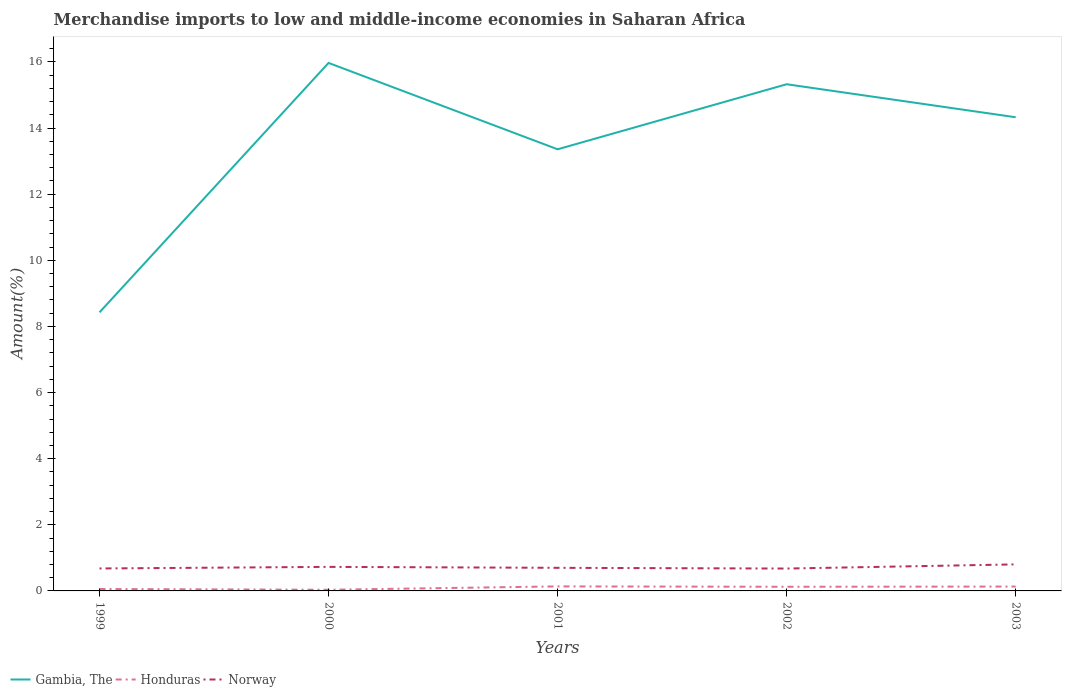How many different coloured lines are there?
Make the answer very short. 3. Does the line corresponding to Gambia, The intersect with the line corresponding to Honduras?
Your answer should be compact. No. Is the number of lines equal to the number of legend labels?
Provide a succinct answer. Yes. Across all years, what is the maximum percentage of amount earned from merchandise imports in Norway?
Your answer should be compact. 0.68. In which year was the percentage of amount earned from merchandise imports in Honduras maximum?
Your answer should be very brief. 2000. What is the total percentage of amount earned from merchandise imports in Norway in the graph?
Provide a short and direct response. 0.05. What is the difference between the highest and the second highest percentage of amount earned from merchandise imports in Honduras?
Your answer should be very brief. 0.1. Is the percentage of amount earned from merchandise imports in Honduras strictly greater than the percentage of amount earned from merchandise imports in Norway over the years?
Keep it short and to the point. Yes. Are the values on the major ticks of Y-axis written in scientific E-notation?
Give a very brief answer. No. Does the graph contain any zero values?
Offer a very short reply. No. Does the graph contain grids?
Make the answer very short. No. Where does the legend appear in the graph?
Your response must be concise. Bottom left. How many legend labels are there?
Offer a terse response. 3. How are the legend labels stacked?
Provide a short and direct response. Horizontal. What is the title of the graph?
Your response must be concise. Merchandise imports to low and middle-income economies in Saharan Africa. Does "Micronesia" appear as one of the legend labels in the graph?
Provide a short and direct response. No. What is the label or title of the X-axis?
Keep it short and to the point. Years. What is the label or title of the Y-axis?
Provide a short and direct response. Amount(%). What is the Amount(%) in Gambia, The in 1999?
Your response must be concise. 8.43. What is the Amount(%) of Honduras in 1999?
Provide a succinct answer. 0.06. What is the Amount(%) of Norway in 1999?
Provide a succinct answer. 0.68. What is the Amount(%) in Gambia, The in 2000?
Offer a very short reply. 15.97. What is the Amount(%) of Honduras in 2000?
Your response must be concise. 0.04. What is the Amount(%) of Norway in 2000?
Give a very brief answer. 0.73. What is the Amount(%) in Gambia, The in 2001?
Offer a terse response. 13.36. What is the Amount(%) in Honduras in 2001?
Offer a terse response. 0.14. What is the Amount(%) in Norway in 2001?
Provide a short and direct response. 0.7. What is the Amount(%) of Gambia, The in 2002?
Offer a very short reply. 15.33. What is the Amount(%) of Honduras in 2002?
Your answer should be compact. 0.13. What is the Amount(%) in Norway in 2002?
Offer a very short reply. 0.68. What is the Amount(%) in Gambia, The in 2003?
Your answer should be very brief. 14.33. What is the Amount(%) in Honduras in 2003?
Provide a short and direct response. 0.13. What is the Amount(%) of Norway in 2003?
Give a very brief answer. 0.8. Across all years, what is the maximum Amount(%) of Gambia, The?
Your answer should be compact. 15.97. Across all years, what is the maximum Amount(%) in Honduras?
Make the answer very short. 0.14. Across all years, what is the maximum Amount(%) in Norway?
Keep it short and to the point. 0.8. Across all years, what is the minimum Amount(%) in Gambia, The?
Your answer should be compact. 8.43. Across all years, what is the minimum Amount(%) in Honduras?
Give a very brief answer. 0.04. Across all years, what is the minimum Amount(%) in Norway?
Offer a terse response. 0.68. What is the total Amount(%) in Gambia, The in the graph?
Your answer should be compact. 67.41. What is the total Amount(%) in Honduras in the graph?
Offer a very short reply. 0.49. What is the total Amount(%) of Norway in the graph?
Give a very brief answer. 3.58. What is the difference between the Amount(%) in Gambia, The in 1999 and that in 2000?
Keep it short and to the point. -7.54. What is the difference between the Amount(%) in Honduras in 1999 and that in 2000?
Your answer should be compact. 0.02. What is the difference between the Amount(%) of Norway in 1999 and that in 2000?
Offer a very short reply. -0.05. What is the difference between the Amount(%) of Gambia, The in 1999 and that in 2001?
Offer a terse response. -4.93. What is the difference between the Amount(%) of Honduras in 1999 and that in 2001?
Provide a succinct answer. -0.08. What is the difference between the Amount(%) of Norway in 1999 and that in 2001?
Your answer should be compact. -0.02. What is the difference between the Amount(%) of Gambia, The in 1999 and that in 2002?
Keep it short and to the point. -6.9. What is the difference between the Amount(%) of Honduras in 1999 and that in 2002?
Provide a succinct answer. -0.07. What is the difference between the Amount(%) in Norway in 1999 and that in 2002?
Provide a succinct answer. 0. What is the difference between the Amount(%) in Gambia, The in 1999 and that in 2003?
Your response must be concise. -5.9. What is the difference between the Amount(%) in Honduras in 1999 and that in 2003?
Offer a very short reply. -0.07. What is the difference between the Amount(%) of Norway in 1999 and that in 2003?
Your answer should be very brief. -0.12. What is the difference between the Amount(%) in Gambia, The in 2000 and that in 2001?
Provide a succinct answer. 2.61. What is the difference between the Amount(%) of Honduras in 2000 and that in 2001?
Your answer should be very brief. -0.1. What is the difference between the Amount(%) of Norway in 2000 and that in 2001?
Provide a succinct answer. 0.03. What is the difference between the Amount(%) in Gambia, The in 2000 and that in 2002?
Offer a very short reply. 0.65. What is the difference between the Amount(%) of Honduras in 2000 and that in 2002?
Offer a very short reply. -0.09. What is the difference between the Amount(%) of Norway in 2000 and that in 2002?
Ensure brevity in your answer.  0.05. What is the difference between the Amount(%) of Gambia, The in 2000 and that in 2003?
Your answer should be very brief. 1.64. What is the difference between the Amount(%) of Honduras in 2000 and that in 2003?
Your answer should be compact. -0.1. What is the difference between the Amount(%) of Norway in 2000 and that in 2003?
Give a very brief answer. -0.08. What is the difference between the Amount(%) of Gambia, The in 2001 and that in 2002?
Provide a short and direct response. -1.97. What is the difference between the Amount(%) of Honduras in 2001 and that in 2002?
Offer a very short reply. 0.01. What is the difference between the Amount(%) in Norway in 2001 and that in 2002?
Give a very brief answer. 0.02. What is the difference between the Amount(%) of Gambia, The in 2001 and that in 2003?
Your response must be concise. -0.97. What is the difference between the Amount(%) in Honduras in 2001 and that in 2003?
Make the answer very short. 0. What is the difference between the Amount(%) of Norway in 2001 and that in 2003?
Offer a terse response. -0.1. What is the difference between the Amount(%) of Honduras in 2002 and that in 2003?
Provide a succinct answer. -0.01. What is the difference between the Amount(%) of Norway in 2002 and that in 2003?
Keep it short and to the point. -0.13. What is the difference between the Amount(%) in Gambia, The in 1999 and the Amount(%) in Honduras in 2000?
Give a very brief answer. 8.39. What is the difference between the Amount(%) of Gambia, The in 1999 and the Amount(%) of Norway in 2000?
Your response must be concise. 7.7. What is the difference between the Amount(%) in Honduras in 1999 and the Amount(%) in Norway in 2000?
Ensure brevity in your answer.  -0.67. What is the difference between the Amount(%) in Gambia, The in 1999 and the Amount(%) in Honduras in 2001?
Make the answer very short. 8.29. What is the difference between the Amount(%) in Gambia, The in 1999 and the Amount(%) in Norway in 2001?
Offer a very short reply. 7.73. What is the difference between the Amount(%) in Honduras in 1999 and the Amount(%) in Norway in 2001?
Ensure brevity in your answer.  -0.64. What is the difference between the Amount(%) of Gambia, The in 1999 and the Amount(%) of Honduras in 2002?
Ensure brevity in your answer.  8.3. What is the difference between the Amount(%) of Gambia, The in 1999 and the Amount(%) of Norway in 2002?
Ensure brevity in your answer.  7.75. What is the difference between the Amount(%) in Honduras in 1999 and the Amount(%) in Norway in 2002?
Provide a short and direct response. -0.62. What is the difference between the Amount(%) in Gambia, The in 1999 and the Amount(%) in Honduras in 2003?
Make the answer very short. 8.29. What is the difference between the Amount(%) of Gambia, The in 1999 and the Amount(%) of Norway in 2003?
Offer a very short reply. 7.62. What is the difference between the Amount(%) of Honduras in 1999 and the Amount(%) of Norway in 2003?
Provide a succinct answer. -0.74. What is the difference between the Amount(%) of Gambia, The in 2000 and the Amount(%) of Honduras in 2001?
Your response must be concise. 15.83. What is the difference between the Amount(%) of Gambia, The in 2000 and the Amount(%) of Norway in 2001?
Offer a very short reply. 15.27. What is the difference between the Amount(%) in Honduras in 2000 and the Amount(%) in Norway in 2001?
Offer a terse response. -0.66. What is the difference between the Amount(%) of Gambia, The in 2000 and the Amount(%) of Honduras in 2002?
Give a very brief answer. 15.85. What is the difference between the Amount(%) of Gambia, The in 2000 and the Amount(%) of Norway in 2002?
Your answer should be very brief. 15.29. What is the difference between the Amount(%) of Honduras in 2000 and the Amount(%) of Norway in 2002?
Provide a short and direct response. -0.64. What is the difference between the Amount(%) of Gambia, The in 2000 and the Amount(%) of Honduras in 2003?
Your answer should be compact. 15.84. What is the difference between the Amount(%) in Gambia, The in 2000 and the Amount(%) in Norway in 2003?
Keep it short and to the point. 15.17. What is the difference between the Amount(%) of Honduras in 2000 and the Amount(%) of Norway in 2003?
Your answer should be compact. -0.77. What is the difference between the Amount(%) of Gambia, The in 2001 and the Amount(%) of Honduras in 2002?
Offer a terse response. 13.23. What is the difference between the Amount(%) of Gambia, The in 2001 and the Amount(%) of Norway in 2002?
Your answer should be compact. 12.68. What is the difference between the Amount(%) in Honduras in 2001 and the Amount(%) in Norway in 2002?
Ensure brevity in your answer.  -0.54. What is the difference between the Amount(%) in Gambia, The in 2001 and the Amount(%) in Honduras in 2003?
Your answer should be compact. 13.23. What is the difference between the Amount(%) in Gambia, The in 2001 and the Amount(%) in Norway in 2003?
Your answer should be compact. 12.56. What is the difference between the Amount(%) of Honduras in 2001 and the Amount(%) of Norway in 2003?
Your answer should be compact. -0.67. What is the difference between the Amount(%) in Gambia, The in 2002 and the Amount(%) in Honduras in 2003?
Give a very brief answer. 15.19. What is the difference between the Amount(%) in Gambia, The in 2002 and the Amount(%) in Norway in 2003?
Provide a succinct answer. 14.52. What is the difference between the Amount(%) of Honduras in 2002 and the Amount(%) of Norway in 2003?
Ensure brevity in your answer.  -0.68. What is the average Amount(%) of Gambia, The per year?
Provide a succinct answer. 13.48. What is the average Amount(%) in Honduras per year?
Your answer should be very brief. 0.1. What is the average Amount(%) of Norway per year?
Give a very brief answer. 0.72. In the year 1999, what is the difference between the Amount(%) in Gambia, The and Amount(%) in Honduras?
Provide a succinct answer. 8.37. In the year 1999, what is the difference between the Amount(%) in Gambia, The and Amount(%) in Norway?
Offer a terse response. 7.75. In the year 1999, what is the difference between the Amount(%) in Honduras and Amount(%) in Norway?
Ensure brevity in your answer.  -0.62. In the year 2000, what is the difference between the Amount(%) in Gambia, The and Amount(%) in Honduras?
Your response must be concise. 15.94. In the year 2000, what is the difference between the Amount(%) of Gambia, The and Amount(%) of Norway?
Ensure brevity in your answer.  15.24. In the year 2000, what is the difference between the Amount(%) of Honduras and Amount(%) of Norway?
Keep it short and to the point. -0.69. In the year 2001, what is the difference between the Amount(%) of Gambia, The and Amount(%) of Honduras?
Offer a terse response. 13.22. In the year 2001, what is the difference between the Amount(%) of Gambia, The and Amount(%) of Norway?
Provide a succinct answer. 12.66. In the year 2001, what is the difference between the Amount(%) in Honduras and Amount(%) in Norway?
Your answer should be very brief. -0.56. In the year 2002, what is the difference between the Amount(%) of Gambia, The and Amount(%) of Honduras?
Your answer should be compact. 15.2. In the year 2002, what is the difference between the Amount(%) in Gambia, The and Amount(%) in Norway?
Your answer should be compact. 14.65. In the year 2002, what is the difference between the Amount(%) of Honduras and Amount(%) of Norway?
Make the answer very short. -0.55. In the year 2003, what is the difference between the Amount(%) in Gambia, The and Amount(%) in Honduras?
Ensure brevity in your answer.  14.2. In the year 2003, what is the difference between the Amount(%) of Gambia, The and Amount(%) of Norway?
Keep it short and to the point. 13.52. In the year 2003, what is the difference between the Amount(%) in Honduras and Amount(%) in Norway?
Your answer should be very brief. -0.67. What is the ratio of the Amount(%) of Gambia, The in 1999 to that in 2000?
Provide a succinct answer. 0.53. What is the ratio of the Amount(%) of Honduras in 1999 to that in 2000?
Provide a short and direct response. 1.65. What is the ratio of the Amount(%) of Norway in 1999 to that in 2000?
Provide a succinct answer. 0.93. What is the ratio of the Amount(%) of Gambia, The in 1999 to that in 2001?
Your answer should be compact. 0.63. What is the ratio of the Amount(%) of Honduras in 1999 to that in 2001?
Your answer should be very brief. 0.42. What is the ratio of the Amount(%) of Norway in 1999 to that in 2001?
Make the answer very short. 0.97. What is the ratio of the Amount(%) of Gambia, The in 1999 to that in 2002?
Your answer should be very brief. 0.55. What is the ratio of the Amount(%) in Honduras in 1999 to that in 2002?
Your response must be concise. 0.46. What is the ratio of the Amount(%) in Norway in 1999 to that in 2002?
Provide a short and direct response. 1. What is the ratio of the Amount(%) of Gambia, The in 1999 to that in 2003?
Make the answer very short. 0.59. What is the ratio of the Amount(%) of Honduras in 1999 to that in 2003?
Your answer should be compact. 0.44. What is the ratio of the Amount(%) in Norway in 1999 to that in 2003?
Provide a short and direct response. 0.85. What is the ratio of the Amount(%) in Gambia, The in 2000 to that in 2001?
Provide a succinct answer. 1.2. What is the ratio of the Amount(%) of Honduras in 2000 to that in 2001?
Give a very brief answer. 0.26. What is the ratio of the Amount(%) of Norway in 2000 to that in 2001?
Ensure brevity in your answer.  1.04. What is the ratio of the Amount(%) of Gambia, The in 2000 to that in 2002?
Provide a succinct answer. 1.04. What is the ratio of the Amount(%) in Honduras in 2000 to that in 2002?
Give a very brief answer. 0.28. What is the ratio of the Amount(%) in Norway in 2000 to that in 2002?
Make the answer very short. 1.07. What is the ratio of the Amount(%) of Gambia, The in 2000 to that in 2003?
Give a very brief answer. 1.11. What is the ratio of the Amount(%) of Honduras in 2000 to that in 2003?
Provide a succinct answer. 0.27. What is the ratio of the Amount(%) of Norway in 2000 to that in 2003?
Your response must be concise. 0.91. What is the ratio of the Amount(%) in Gambia, The in 2001 to that in 2002?
Keep it short and to the point. 0.87. What is the ratio of the Amount(%) in Honduras in 2001 to that in 2002?
Give a very brief answer. 1.09. What is the ratio of the Amount(%) of Norway in 2001 to that in 2002?
Provide a short and direct response. 1.03. What is the ratio of the Amount(%) of Gambia, The in 2001 to that in 2003?
Ensure brevity in your answer.  0.93. What is the ratio of the Amount(%) in Honduras in 2001 to that in 2003?
Offer a terse response. 1.04. What is the ratio of the Amount(%) of Norway in 2001 to that in 2003?
Your response must be concise. 0.87. What is the ratio of the Amount(%) in Gambia, The in 2002 to that in 2003?
Offer a terse response. 1.07. What is the ratio of the Amount(%) in Honduras in 2002 to that in 2003?
Your answer should be very brief. 0.95. What is the ratio of the Amount(%) of Norway in 2002 to that in 2003?
Make the answer very short. 0.84. What is the difference between the highest and the second highest Amount(%) of Gambia, The?
Your answer should be very brief. 0.65. What is the difference between the highest and the second highest Amount(%) of Honduras?
Keep it short and to the point. 0. What is the difference between the highest and the second highest Amount(%) in Norway?
Provide a succinct answer. 0.08. What is the difference between the highest and the lowest Amount(%) in Gambia, The?
Offer a very short reply. 7.54. What is the difference between the highest and the lowest Amount(%) of Honduras?
Your answer should be compact. 0.1. What is the difference between the highest and the lowest Amount(%) in Norway?
Ensure brevity in your answer.  0.13. 